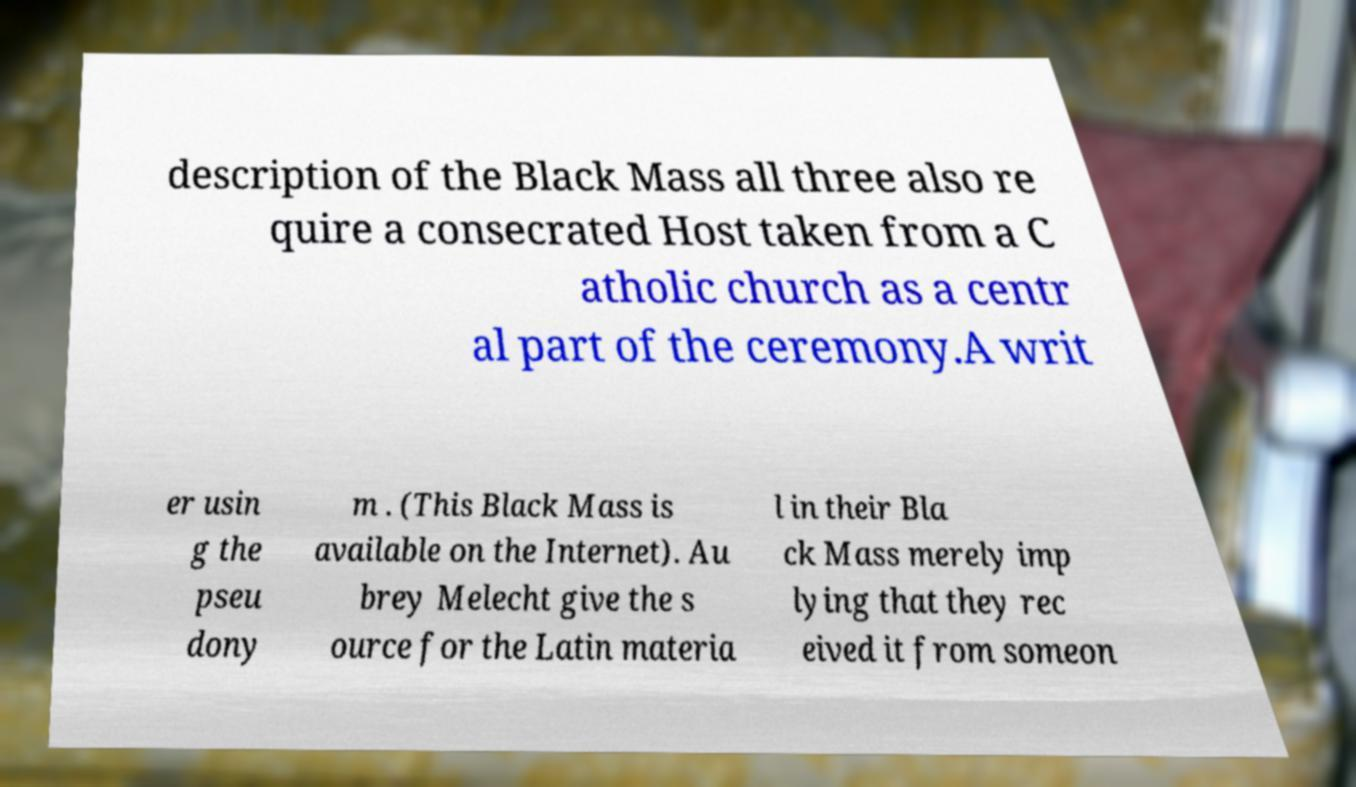What messages or text are displayed in this image? I need them in a readable, typed format. description of the Black Mass all three also re quire a consecrated Host taken from a C atholic church as a centr al part of the ceremony.A writ er usin g the pseu dony m . (This Black Mass is available on the Internet). Au brey Melecht give the s ource for the Latin materia l in their Bla ck Mass merely imp lying that they rec eived it from someon 